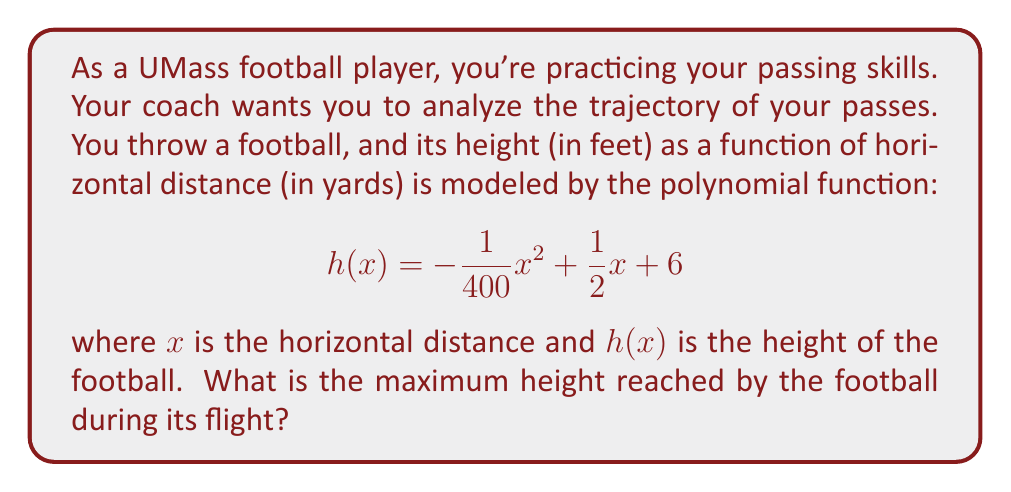What is the answer to this math problem? To find the maximum height of the football's trajectory, we need to follow these steps:

1) The polynomial function given is a quadratic function in the form $f(x) = ax^2 + bx + c$, where:
   $a = -\frac{1}{400}$, $b = \frac{1}{2}$, and $c = 6$

2) For a quadratic function, the x-coordinate of the vertex represents the point where the function reaches its maximum (if $a < 0$) or minimum (if $a > 0$).

3) The formula for the x-coordinate of the vertex is: $x = -\frac{b}{2a}$

4) Substituting our values:
   $$x = -\frac{\frac{1}{2}}{2(-\frac{1}{400})} = -\frac{1}{2} \cdot (-800) = 100$$

5) This means the football reaches its maximum height when $x = 100$ yards.

6) To find the maximum height, we need to calculate $h(100)$:

   $$\begin{align}
   h(100) &= -\frac{1}{400}(100)^2 + \frac{1}{2}(100) + 6 \\
   &= -25 + 50 + 6 \\
   &= 31
   \end{align}$$

Therefore, the maximum height reached by the football is 31 feet.
Answer: 31 feet 